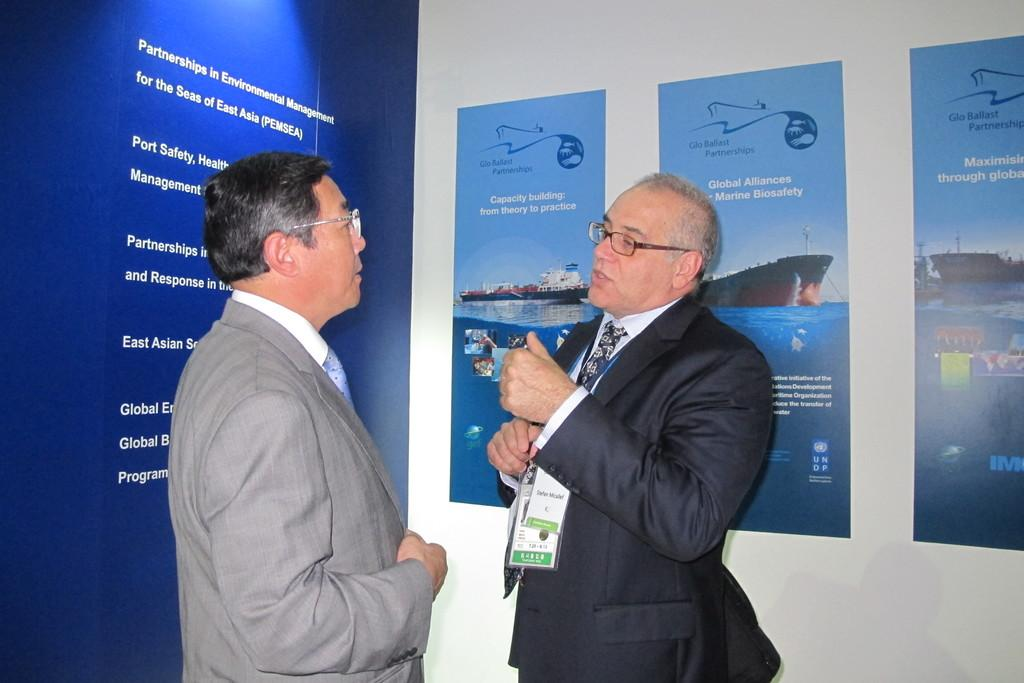How many people are in the image? There are two persons in the image. What is located behind the persons in the image? There is a wall in the image. What can be seen on the wall in the image? There are posters with text and images on the wall. What type of pie is being served on the table in the image? There is no table or pie present in the image; it only features two persons and a wall with posters. 